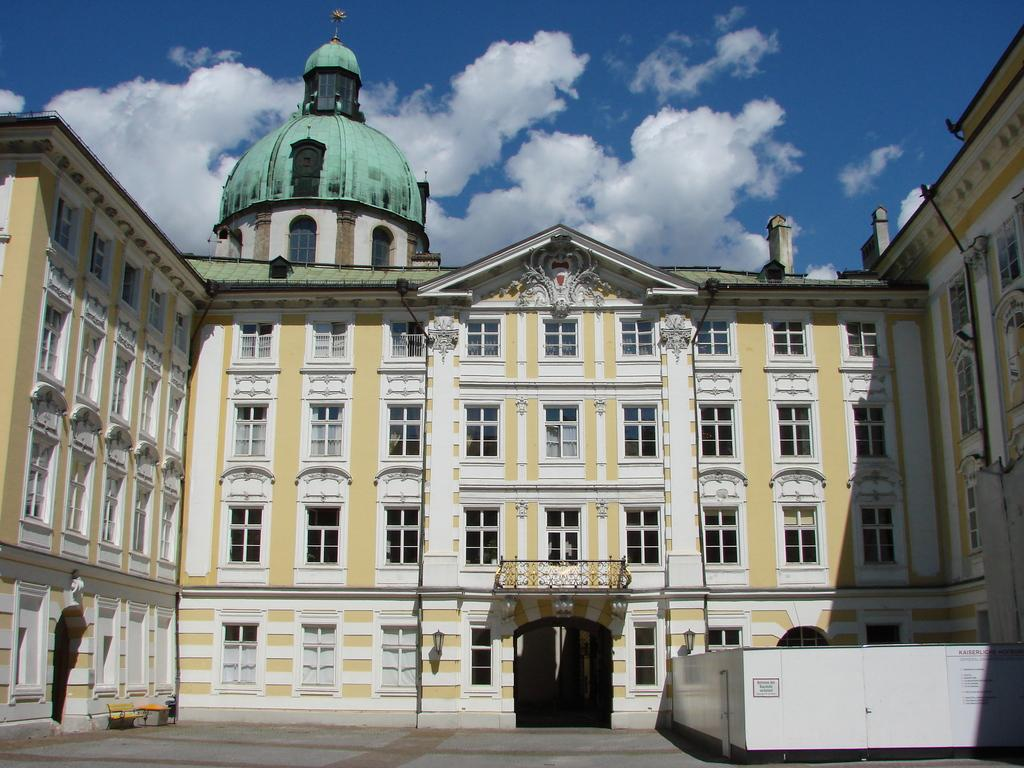What color is the building in the image? The building is white in color. What is the condition of the sky in the image? The sky is cloudy at the top of the image. What type of collar is visible on the building in the image? There is no collar present on the building in the image. How many accounts are associated with the building in the image? There is no information about accounts in the image; it only shows a white building and a cloudy sky. 